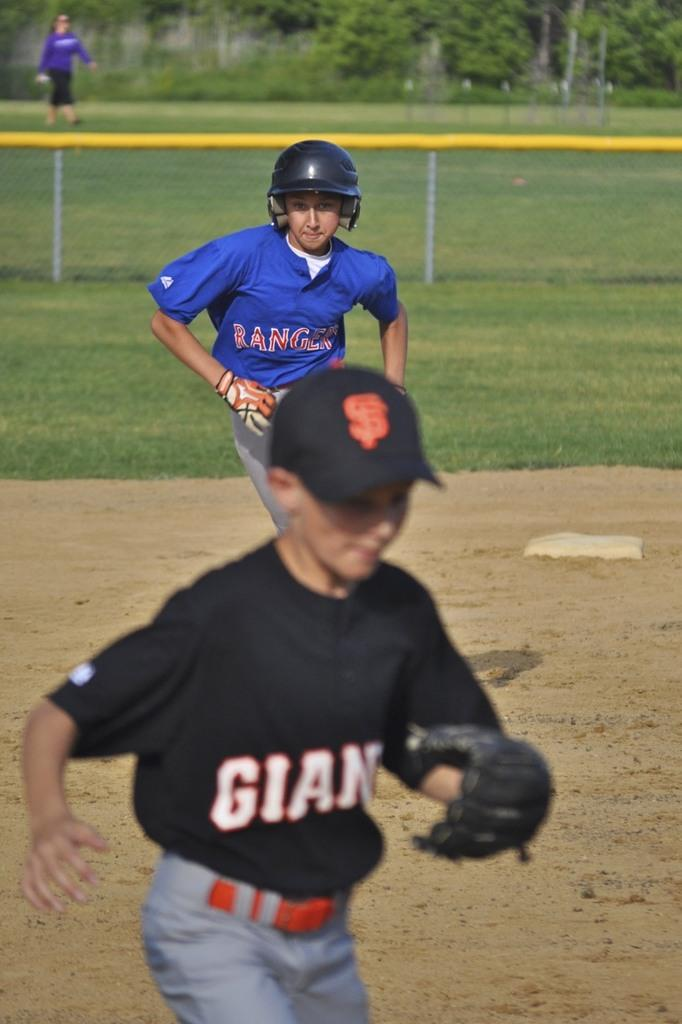<image>
Offer a succinct explanation of the picture presented. The Giants are playing the Rangers and there is a yellow top on the fence around the ball park. 